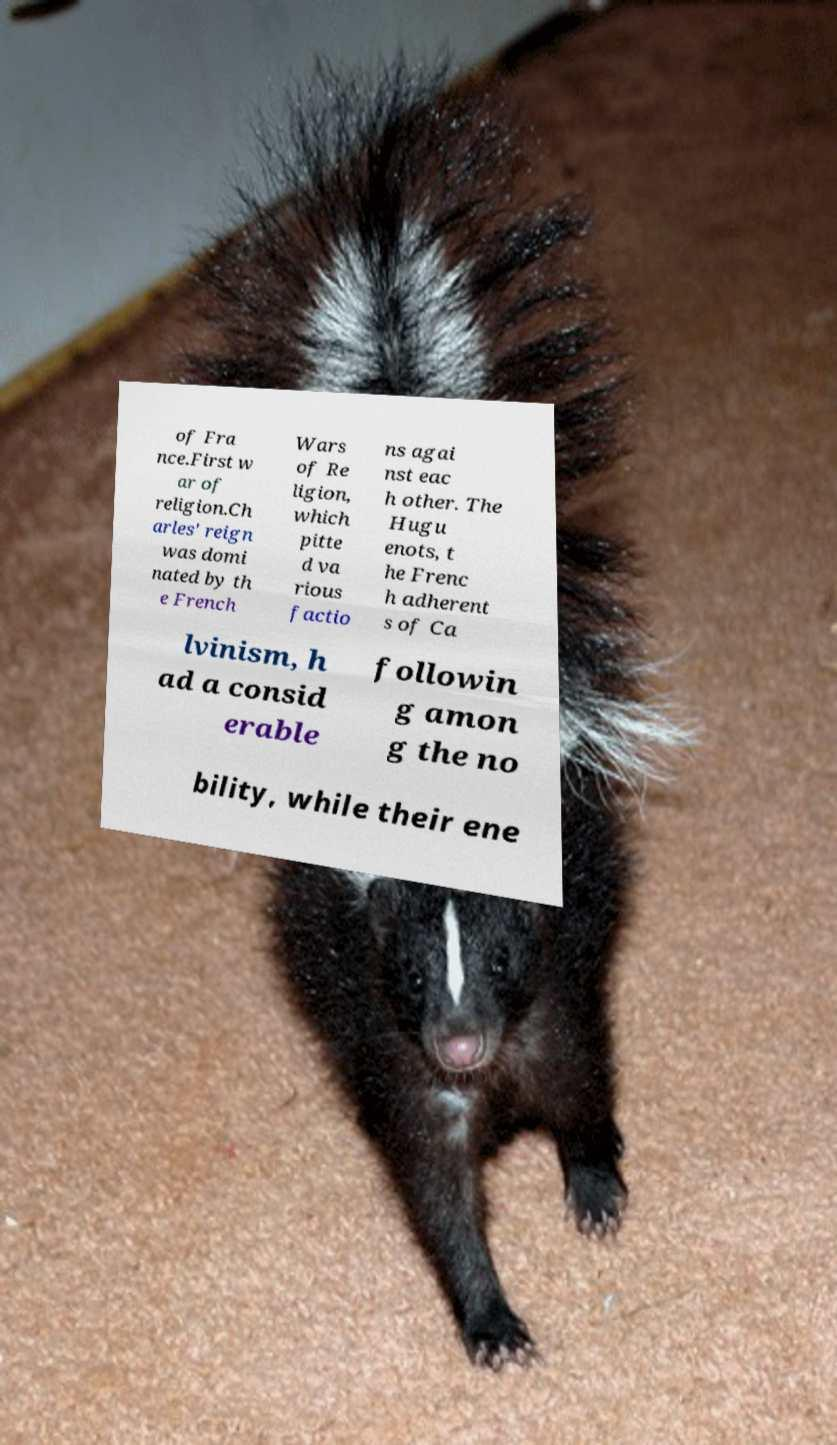What messages or text are displayed in this image? I need them in a readable, typed format. of Fra nce.First w ar of religion.Ch arles' reign was domi nated by th e French Wars of Re ligion, which pitte d va rious factio ns agai nst eac h other. The Hugu enots, t he Frenc h adherent s of Ca lvinism, h ad a consid erable followin g amon g the no bility, while their ene 